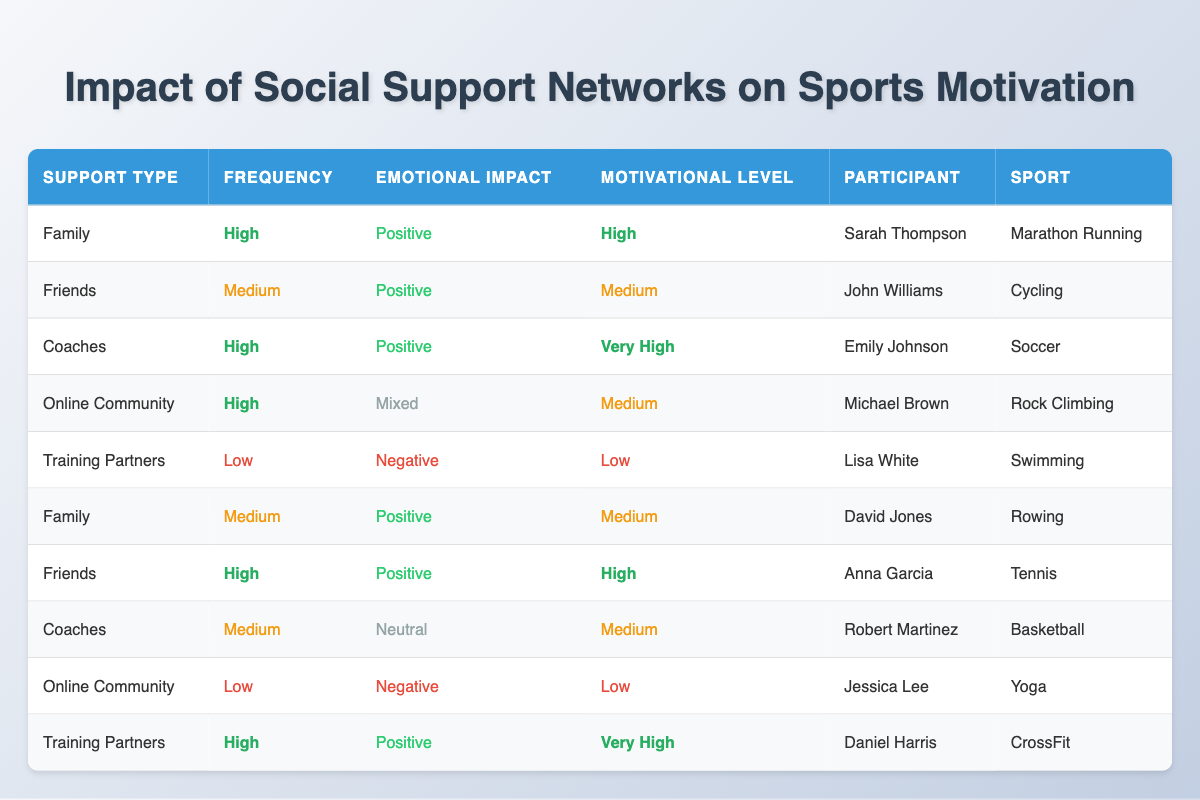What is the motivational level of Sarah Thompson? Sarah Thompson is listed in the table under the category of Family support with a motivational level marked as High.
Answer: High Which sport has the participant with the highest motivational level? By reviewing the motivational levels in the table, it can be seen that the highest level is marked as Very High, which corresponds to Daniel Harris in CrossFit.
Answer: CrossFit Is the emotional impact of support from Training Partners always negative? In the table, there are two entries for Training Partners; one has a negative emotional impact while the other has a positive emotional impact, which means it is not always negative.
Answer: No What type of support has the most participants listed? A close examination of the table shows that both Family and Friends have three participants each, indicating that those types of support have the most entries.
Answer: Family and Friends If we consider the average motivational level for all support types based on a numerical scale (Low = 1, Medium = 2, High = 3, Very High = 4), what is the average? The motivational levels in the table translate to numerical values: High (3), Medium (2), Very High (4), and Low (1). There are 10 total levels: [3, 2, 3, 2, 1, 2, 3, 2, 1, 4], summing them gives a total of 23. Dividing by 10 participants gives an average of 2.3, rounded down.
Answer: 2.3 How many participants reported a motivational level of Low? Examining the table, there are two participants, Lisa White and Jessica Lee, who reported a motivational level of Low under Training Partners and Online Community respectively.
Answer: 2 Is there any participant whose emotional impact from social support is neutral? Reviewing the emotional impacts listed in the table, Robert Martinez's entry under Coaches shows a neutral emotional impact.
Answer: Yes Which type of social support is associated with the highest frequency of interaction? Looking at the frequency column, both Coaches and Family show a high frequency of support, but Coaches is associated with a very high motivational level, indicating significant effectiveness.
Answer: Coaches Which participant received emotional support from an Online Community? The table identifies Michael Brown as receiving support from an Online Community.
Answer: Michael Brown What is the emotional impact of support for the participant in Yoga? The entry for Jessica Lee indicates that the emotional impact of her support from the Online Community is negative.
Answer: Negative 